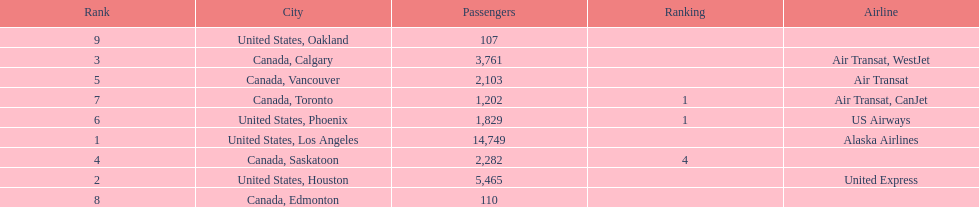How many more passengers flew to los angeles than to saskatoon from manzanillo airport in 2013? 12,467. 